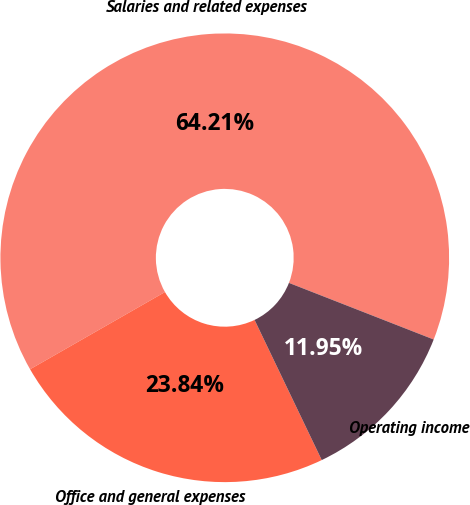Convert chart to OTSL. <chart><loc_0><loc_0><loc_500><loc_500><pie_chart><fcel>Salaries and related expenses<fcel>Office and general expenses<fcel>Operating income<nl><fcel>64.21%<fcel>23.84%<fcel>11.95%<nl></chart> 